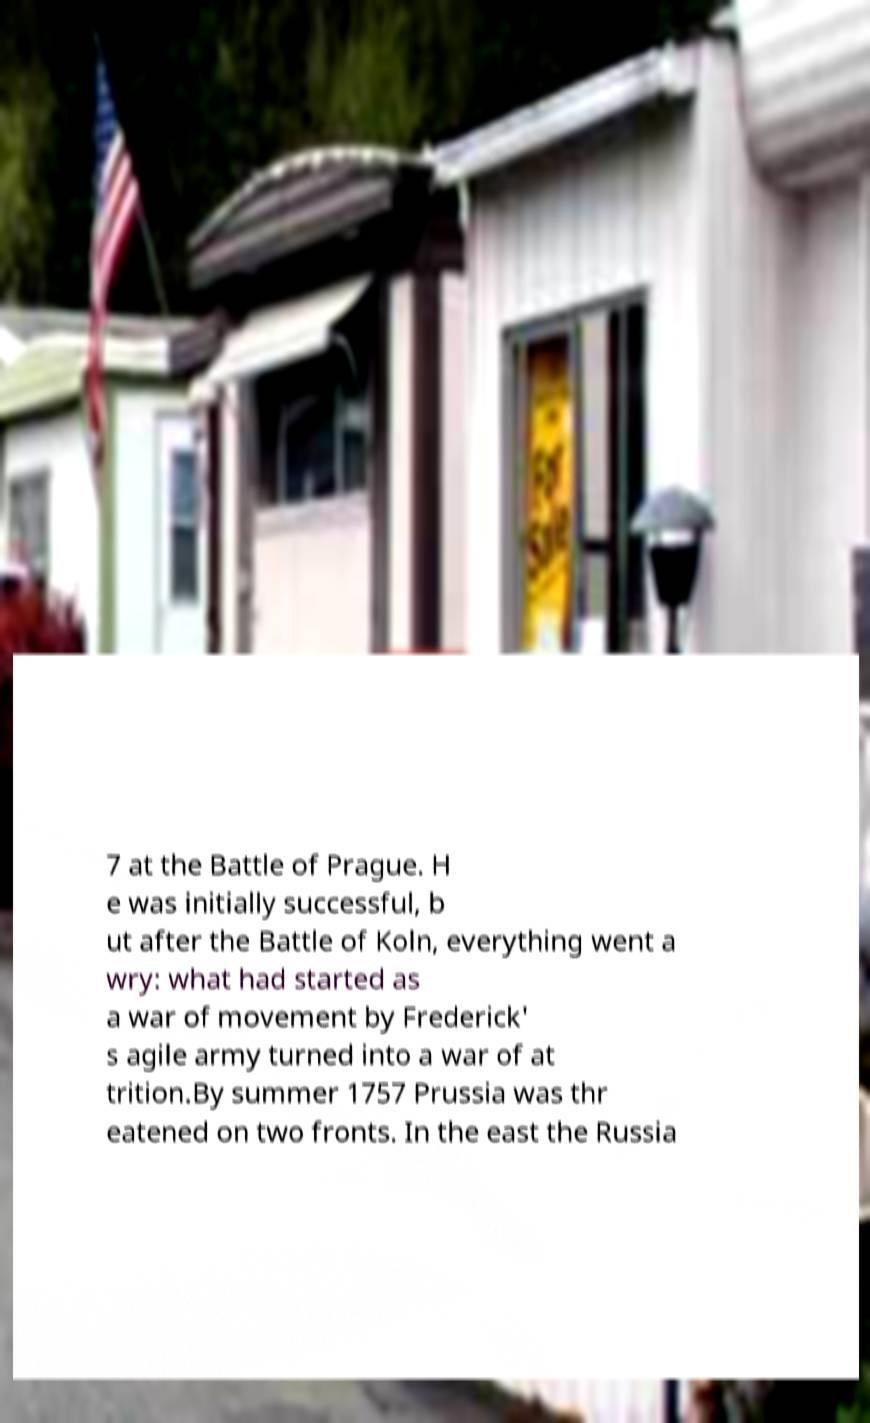For documentation purposes, I need the text within this image transcribed. Could you provide that? 7 at the Battle of Prague. H e was initially successful, b ut after the Battle of Koln, everything went a wry: what had started as a war of movement by Frederick' s agile army turned into a war of at trition.By summer 1757 Prussia was thr eatened on two fronts. In the east the Russia 